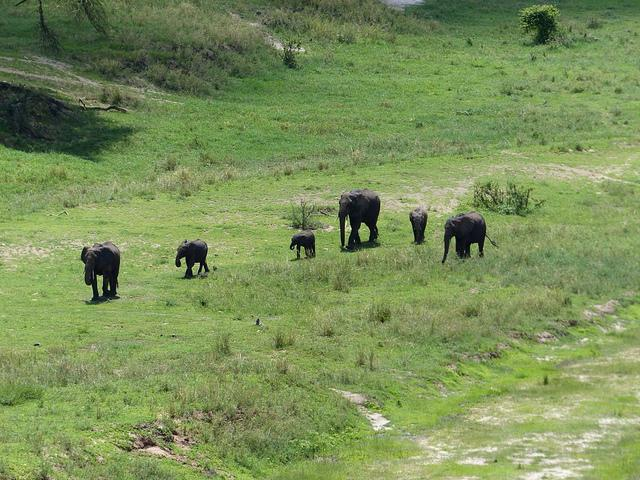What is the littlest elephant called?

Choices:
A) pup
B) colt
C) squab
D) calf calf 